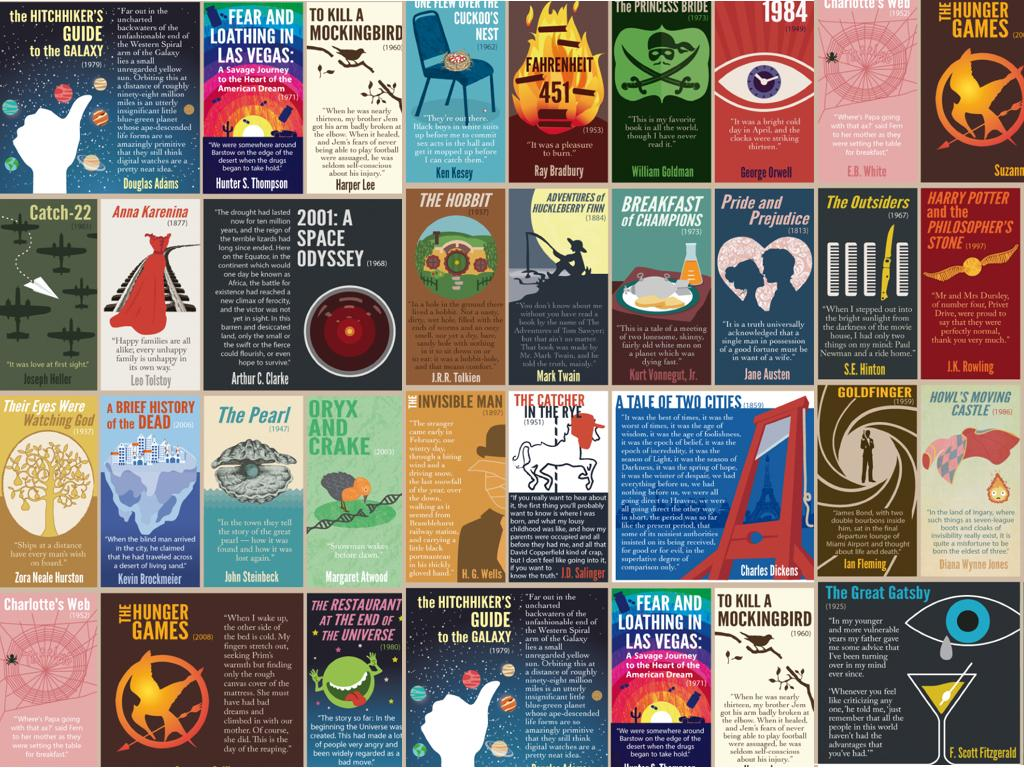Outline some significant characteristics in this image. The author of the book "To Kill a Mockingbird" is Harper Lee. Pride and Prejudice" was written by Jane Austen. The book "Adventures of Huckleberry Finn," written by Mark Twain, is depicted in this infographic. Ray Bradbury wrote the book "Fahrenheit 451. The book "Anna Karenina" was written by Leo Tolstoy. 